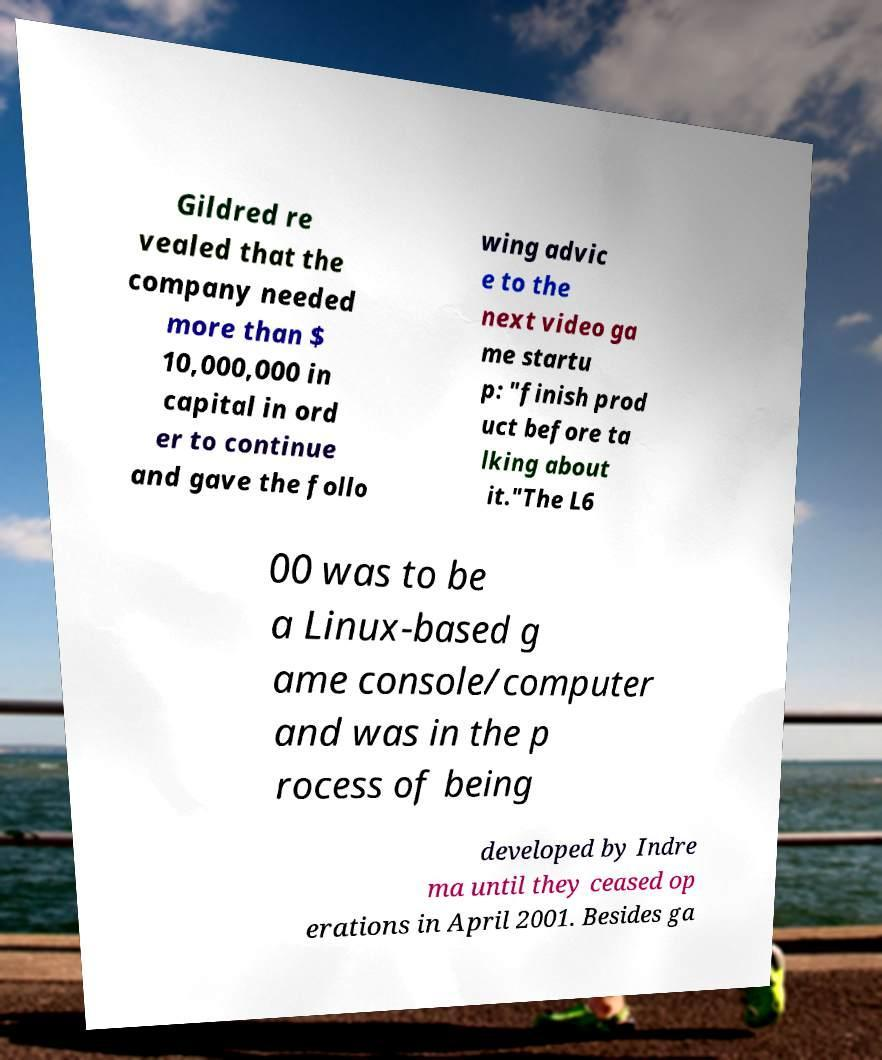What messages or text are displayed in this image? I need them in a readable, typed format. Gildred re vealed that the company needed more than $ 10,000,000 in capital in ord er to continue and gave the follo wing advic e to the next video ga me startu p: "finish prod uct before ta lking about it."The L6 00 was to be a Linux-based g ame console/computer and was in the p rocess of being developed by Indre ma until they ceased op erations in April 2001. Besides ga 